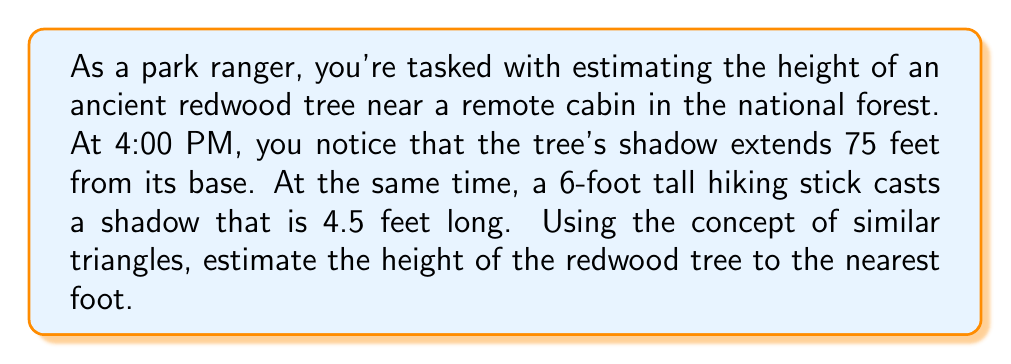Can you solve this math problem? Let's approach this problem step-by-step using the concept of similar triangles:

1) We can form two similar triangles:
   a) One triangle formed by the tree and its shadow
   b) Another triangle formed by the hiking stick and its shadow

2) Let's define our variables:
   $h$ = height of the tree (unknown)
   $s$ = length of the tree's shadow = 75 feet
   $H$ = height of the hiking stick = 6 feet
   $S$ = length of the hiking stick's shadow = 4.5 feet

3) Since these triangles are similar, their ratios are equal:

   $$\frac{h}{s} = \frac{H}{S}$$

4) We can cross-multiply to solve for $h$:

   $$h \cdot S = s \cdot H$$
   $$h = \frac{s \cdot H}{S}$$

5) Now, let's substitute our known values:

   $$h = \frac{75 \cdot 6}{4.5}$$

6) Simplify:
   $$h = \frac{450}{4.5} = 100$$

Therefore, the estimated height of the redwood tree is 100 feet.

[asy]
unitsize(1cm);
draw((0,0)--(7.5,0)--(7.5,10)--(0,0),black);
draw((0,0)--(0.45,0)--(0.45,0.6)--(0,0),red);
label("75 ft", (3.75,-0.3), S);
label("4.5 ft", (0.225,-0.3), S);
label("6 ft", (0.5,0.3), E);
label("h = 100 ft", (7.7,5), E);
label("Tree", (4,5), E);
label("Stick", (0.5,0.3), W);
[/asy]
Answer: The estimated height of the redwood tree is 100 feet. 